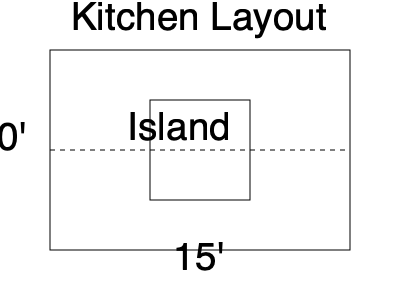Based on the kitchen layout diagram, estimate the total linear feet of countertop material needed for the perimeter and island, assuming a standard overhang of 1.5 inches. Round your answer to the nearest foot. To calculate the total linear feet of countertop material needed, we'll follow these steps:

1. Calculate the perimeter of the kitchen:
   - Length: 15 feet
   - Width: 10 feet
   - Perimeter = $2 \times (15 + 10) = 50$ feet

2. Calculate the perimeter of the island:
   - The island appears to be approximately 5 feet by 5 feet
   - Island perimeter = $4 \times 5 = 20$ feet

3. Sum up the total linear feet:
   - Total = Perimeter + Island = $50 + 20 = 70$ feet

4. Account for the overhang:
   - Standard overhang is 1.5 inches
   - Convert to feet: $1.5 \div 12 = 0.125$ feet
   - Add overhang to each corner: $8 \times 0.125 = 1$ foot (4 corners for perimeter, 4 for island)

5. Final calculation:
   - Total linear feet = $70 + 1 = 71$ feet

Rounding to the nearest foot, the answer remains 71 feet.
Answer: 71 feet 